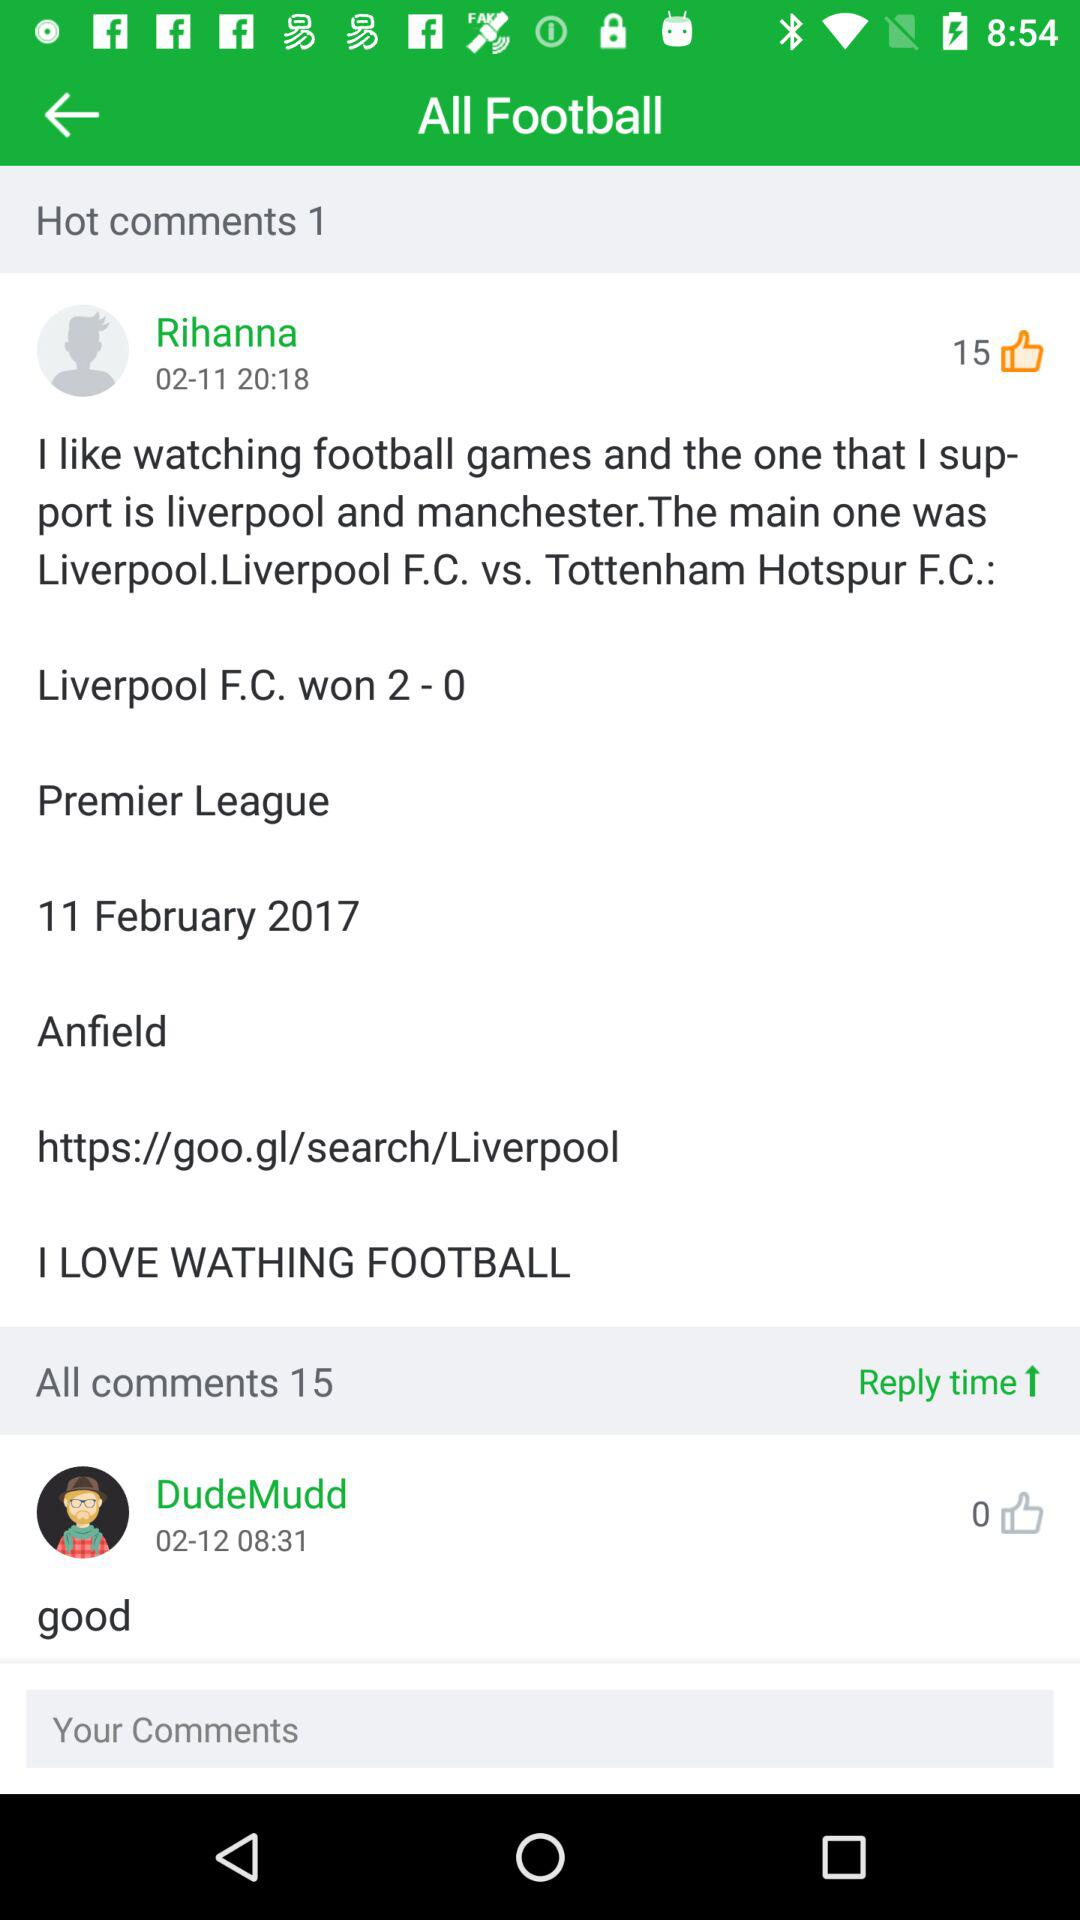Who wins the match? It is Liverpool F.C. 